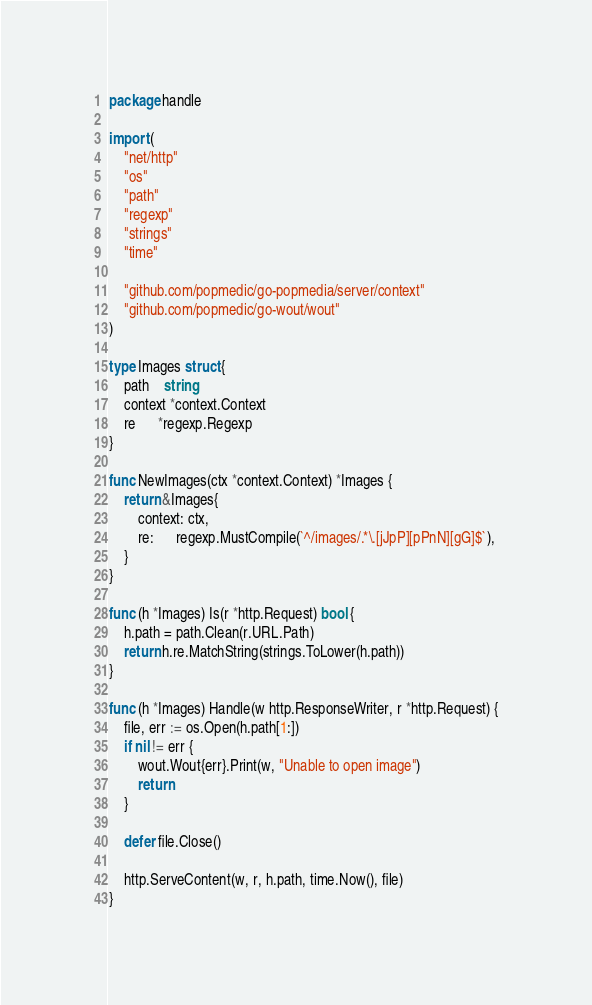Convert code to text. <code><loc_0><loc_0><loc_500><loc_500><_Go_>package handle

import (
	"net/http"
	"os"
	"path"
	"regexp"
	"strings"
	"time"

	"github.com/popmedic/go-popmedia/server/context"
	"github.com/popmedic/go-wout/wout"
)

type Images struct {
	path    string
	context *context.Context
	re      *regexp.Regexp
}

func NewImages(ctx *context.Context) *Images {
	return &Images{
		context: ctx,
		re:      regexp.MustCompile(`^/images/.*\.[jJpP][pPnN][gG]$`),
	}
}

func (h *Images) Is(r *http.Request) bool {
	h.path = path.Clean(r.URL.Path)
	return h.re.MatchString(strings.ToLower(h.path))
}

func (h *Images) Handle(w http.ResponseWriter, r *http.Request) {
	file, err := os.Open(h.path[1:])
	if nil != err {
		wout.Wout{err}.Print(w, "Unable to open image")
		return
	}

	defer file.Close()

	http.ServeContent(w, r, h.path, time.Now(), file)
}
</code> 